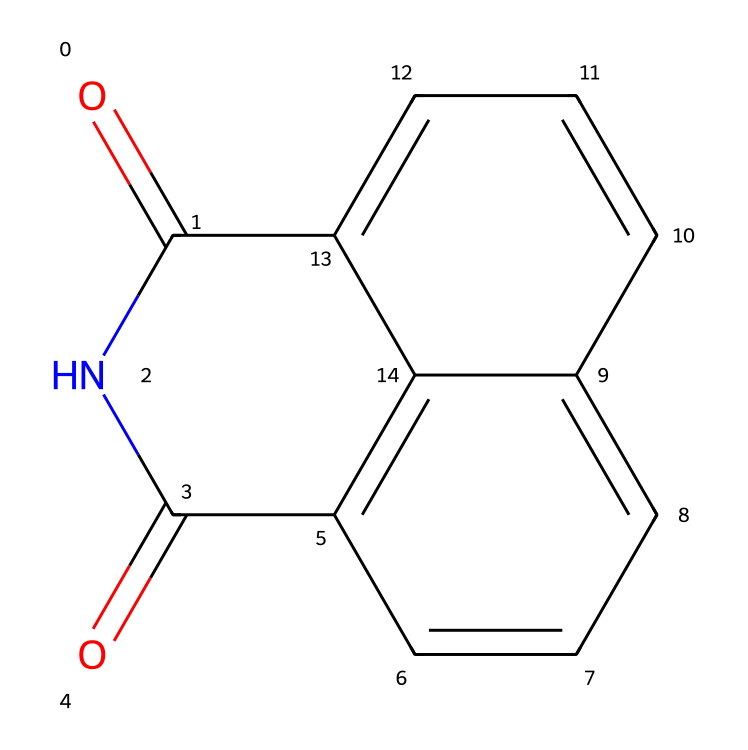What is the molecular formula of naphthalimide? By analyzing the structure, we can count the atoms of different elements: there are 10 carbon atoms, 6 hydrogen atoms, 2 nitrogen atoms, and 2 oxygen atoms. Combining these, the molecular formula is C10H6N2O2.
Answer: C10H6N2O2 How many rings are present in naphthalimide? The structure displays two interconnected aromatic rings that can be counted as two distinct rings in the molecular framework, corresponding to the fused naphthalene structure.
Answer: 2 What type of functional groups are present in naphthalimide? The molecule has imide functional groups, which include nitrogen and carbonyl elements. By identifying the specific characteristics of the groups attached to nitrogen atoms, it is evident that they are part of the imide class.
Answer: imide What is the total number of oxygen atoms in naphthalimide? Observing the SMILES representation indicates there are two occurrences of “O” which confirms the presence of two oxygen atoms in the molecule.
Answer: 2 Is naphthalimide a linear or non-linear molecule? The arrangement of atoms shows that the structure is comprised of fused aromatic rings and a non-linear configuration, thus making it a non-linear molecule.
Answer: non-linear Which atom is responsible for the dye properties of naphthalimide? The nitrogen atoms in the imide group and their connectivity to the aromatic system are significant for the fluorescent properties, indicating the nitrogen atoms’ essential role in these properties.
Answer: nitrogen 